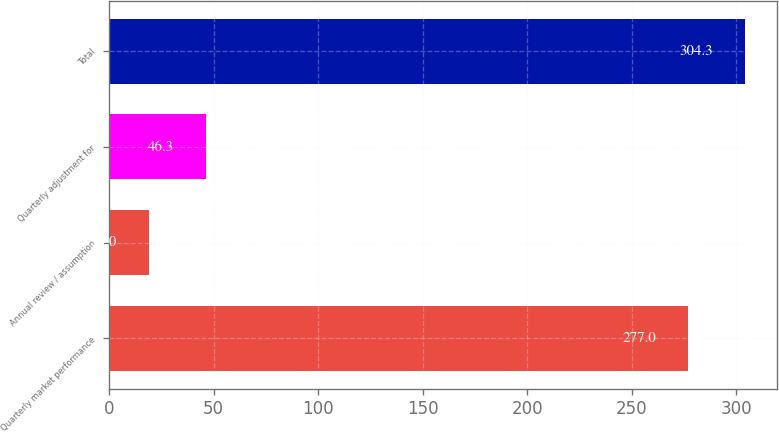Convert chart. <chart><loc_0><loc_0><loc_500><loc_500><bar_chart><fcel>Quarterly market performance<fcel>Annual review / assumption<fcel>Quarterly adjustment for<fcel>Total<nl><fcel>277<fcel>19<fcel>46.3<fcel>304.3<nl></chart> 